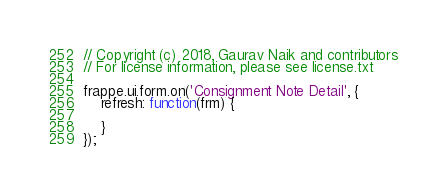<code> <loc_0><loc_0><loc_500><loc_500><_JavaScript_>// Copyright (c) 2018, Gaurav Naik and contributors
// For license information, please see license.txt

frappe.ui.form.on('Consignment Note Detail', {
	refresh: function(frm) {

	}
});
</code> 